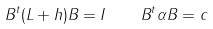<formula> <loc_0><loc_0><loc_500><loc_500>B ^ { t } ( L + h ) B = I \quad B ^ { t } \alpha B = c</formula> 